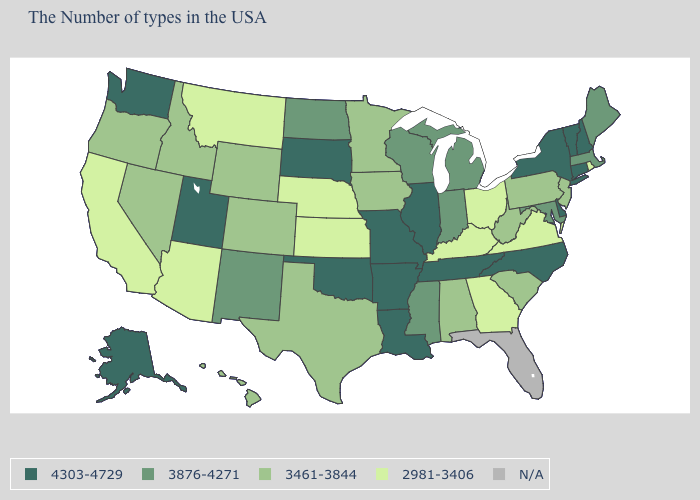Does Idaho have the highest value in the West?
Write a very short answer. No. How many symbols are there in the legend?
Short answer required. 5. What is the value of Idaho?
Quick response, please. 3461-3844. Which states have the highest value in the USA?
Write a very short answer. New Hampshire, Vermont, Connecticut, New York, Delaware, North Carolina, Tennessee, Illinois, Louisiana, Missouri, Arkansas, Oklahoma, South Dakota, Utah, Washington, Alaska. Name the states that have a value in the range 3876-4271?
Keep it brief. Maine, Massachusetts, Maryland, Michigan, Indiana, Wisconsin, Mississippi, North Dakota, New Mexico. Name the states that have a value in the range 3461-3844?
Short answer required. New Jersey, Pennsylvania, South Carolina, West Virginia, Alabama, Minnesota, Iowa, Texas, Wyoming, Colorado, Idaho, Nevada, Oregon, Hawaii. What is the highest value in the MidWest ?
Keep it brief. 4303-4729. Does the map have missing data?
Write a very short answer. Yes. Among the states that border New Jersey , which have the lowest value?
Write a very short answer. Pennsylvania. What is the highest value in the Northeast ?
Be succinct. 4303-4729. Name the states that have a value in the range 3461-3844?
Give a very brief answer. New Jersey, Pennsylvania, South Carolina, West Virginia, Alabama, Minnesota, Iowa, Texas, Wyoming, Colorado, Idaho, Nevada, Oregon, Hawaii. Which states have the lowest value in the MidWest?
Short answer required. Ohio, Kansas, Nebraska. What is the value of Wyoming?
Quick response, please. 3461-3844. Which states have the lowest value in the Northeast?
Short answer required. Rhode Island. Name the states that have a value in the range 3461-3844?
Short answer required. New Jersey, Pennsylvania, South Carolina, West Virginia, Alabama, Minnesota, Iowa, Texas, Wyoming, Colorado, Idaho, Nevada, Oregon, Hawaii. 